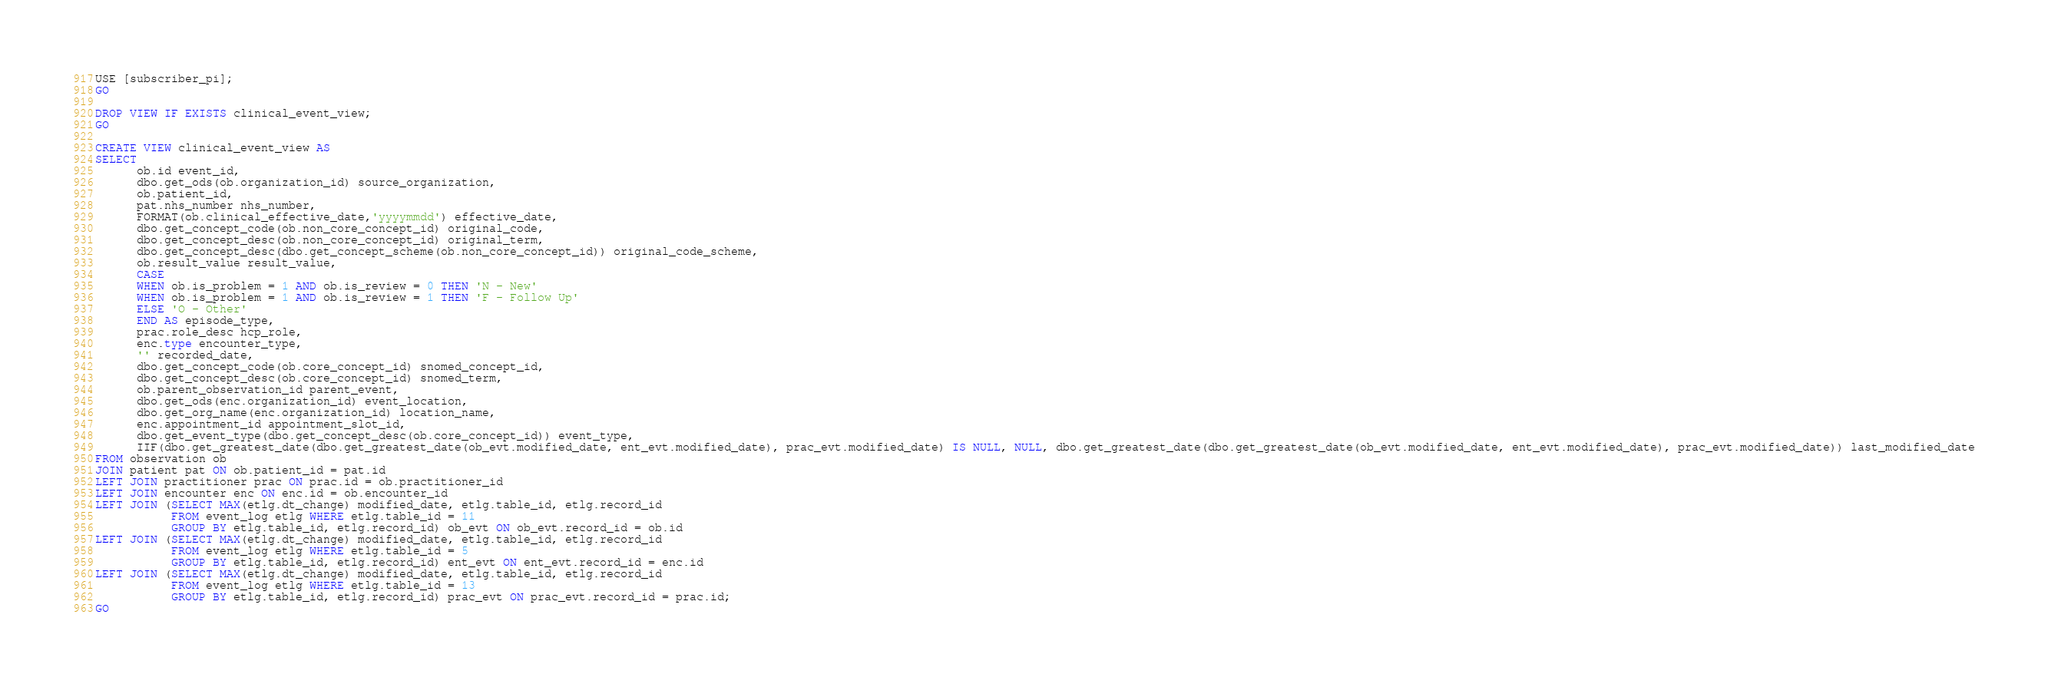Convert code to text. <code><loc_0><loc_0><loc_500><loc_500><_SQL_>USE [subscriber_pi];
GO

DROP VIEW IF EXISTS clinical_event_view;
GO

CREATE VIEW clinical_event_view AS
SELECT 
      ob.id event_id, 
      dbo.get_ods(ob.organization_id) source_organization, 
      ob.patient_id, 
      pat.nhs_number nhs_number,
      FORMAT(ob.clinical_effective_date,'yyyymmdd') effective_date,
      dbo.get_concept_code(ob.non_core_concept_id) original_code,
      dbo.get_concept_desc(ob.non_core_concept_id) original_term,
      dbo.get_concept_desc(dbo.get_concept_scheme(ob.non_core_concept_id)) original_code_scheme,
      ob.result_value result_value,
      CASE 
      WHEN ob.is_problem = 1 AND ob.is_review = 0 THEN 'N - New'
      WHEN ob.is_problem = 1 AND ob.is_review = 1 THEN 'F - Follow Up'
      ELSE 'O - Other'
      END AS episode_type,
      prac.role_desc hcp_role,
      enc.type encounter_type,
      '' recorded_date,
      dbo.get_concept_code(ob.core_concept_id) snomed_concept_id,
      dbo.get_concept_desc(ob.core_concept_id) snomed_term,
      ob.parent_observation_id parent_event,
      dbo.get_ods(enc.organization_id) event_location, 
      dbo.get_org_name(enc.organization_id) location_name,
      enc.appointment_id appointment_slot_id,
      dbo.get_event_type(dbo.get_concept_desc(ob.core_concept_id)) event_type,
      IIF(dbo.get_greatest_date(dbo.get_greatest_date(ob_evt.modified_date, ent_evt.modified_date), prac_evt.modified_date) IS NULL, NULL, dbo.get_greatest_date(dbo.get_greatest_date(ob_evt.modified_date, ent_evt.modified_date), prac_evt.modified_date)) last_modified_date
FROM observation ob 
JOIN patient pat ON ob.patient_id = pat.id
LEFT JOIN practitioner prac ON prac.id = ob.practitioner_id
LEFT JOIN encounter enc ON enc.id = ob.encounter_id
LEFT JOIN (SELECT MAX(etlg.dt_change) modified_date, etlg.table_id, etlg.record_id 
           FROM event_log etlg WHERE etlg.table_id = 11
           GROUP BY etlg.table_id, etlg.record_id) ob_evt ON ob_evt.record_id = ob.id
LEFT JOIN (SELECT MAX(etlg.dt_change) modified_date, etlg.table_id, etlg.record_id 
           FROM event_log etlg WHERE etlg.table_id = 5
           GROUP BY etlg.table_id, etlg.record_id) ent_evt ON ent_evt.record_id = enc.id	
LEFT JOIN (SELECT MAX(etlg.dt_change) modified_date, etlg.table_id, etlg.record_id 
           FROM event_log etlg WHERE etlg.table_id = 13
           GROUP BY etlg.table_id, etlg.record_id) prac_evt ON prac_evt.record_id = prac.id;
GO</code> 